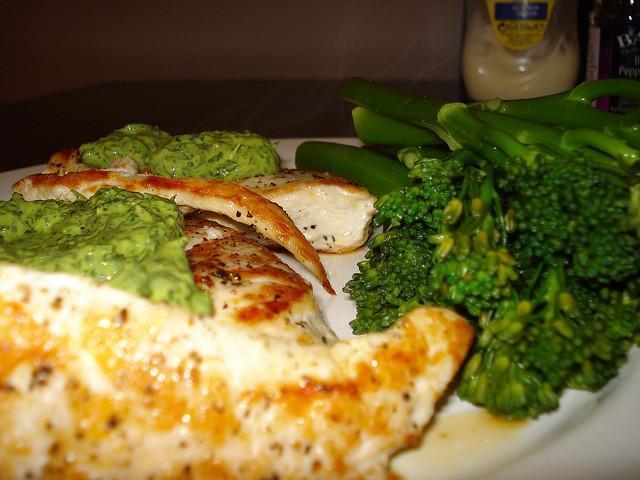Does the caption "The broccoli is beside the pizza." correctly depict the image?
Answer yes or no. Yes. Does the image validate the caption "The broccoli is on the pizza."?
Answer yes or no. No. Does the image validate the caption "The broccoli is at the right side of the pizza."?
Answer yes or no. Yes. Is this affirmation: "The pizza is next to the broccoli." correct?
Answer yes or no. Yes. Does the caption "The broccoli is at the left side of the pizza." correctly depict the image?
Answer yes or no. No. Does the description: "The pizza is under the broccoli." accurately reflect the image?
Answer yes or no. No. Evaluate: Does the caption "The pizza is below the broccoli." match the image?
Answer yes or no. No. 